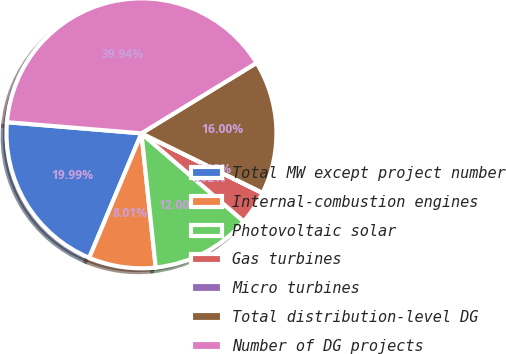Convert chart. <chart><loc_0><loc_0><loc_500><loc_500><pie_chart><fcel>Total MW except project number<fcel>Internal-combustion engines<fcel>Photovoltaic solar<fcel>Gas turbines<fcel>Micro turbines<fcel>Total distribution-level DG<fcel>Number of DG projects<nl><fcel>19.99%<fcel>8.01%<fcel>12.0%<fcel>4.02%<fcel>0.03%<fcel>16.0%<fcel>39.94%<nl></chart> 